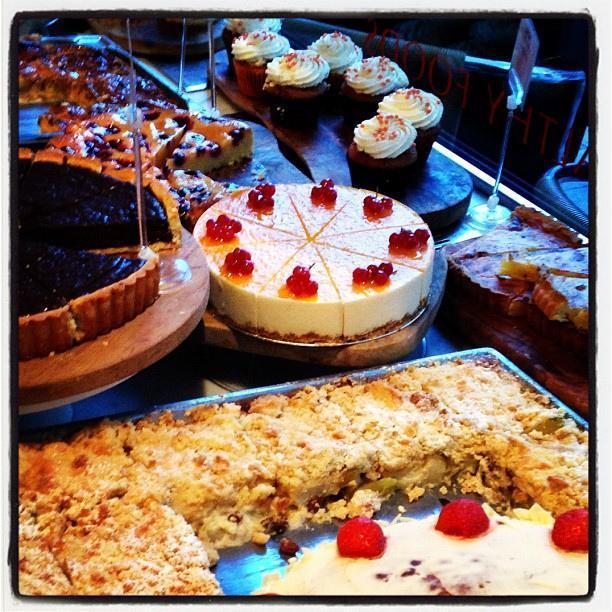How many pieces is the cake cut into?
Give a very brief answer. 8. How many cakes are in the picture?
Give a very brief answer. 11. 